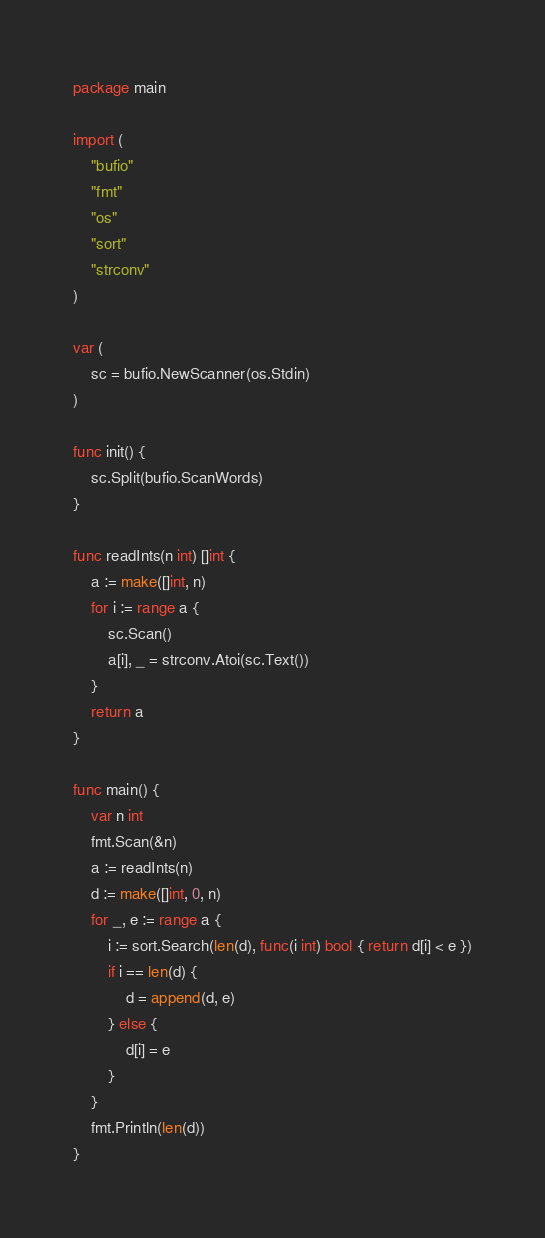<code> <loc_0><loc_0><loc_500><loc_500><_Go_>package main

import (
	"bufio"
	"fmt"
	"os"
	"sort"
	"strconv"
)

var (
	sc = bufio.NewScanner(os.Stdin)
)

func init() {
	sc.Split(bufio.ScanWords)
}

func readInts(n int) []int {
	a := make([]int, n)
	for i := range a {
		sc.Scan()
		a[i], _ = strconv.Atoi(sc.Text())
	}
	return a
}

func main() {
	var n int
	fmt.Scan(&n)
	a := readInts(n)
	d := make([]int, 0, n)
	for _, e := range a {
		i := sort.Search(len(d), func(i int) bool { return d[i] < e })
		if i == len(d) {
			d = append(d, e)
		} else {
			d[i] = e
		}
	}
	fmt.Println(len(d))
}
</code> 